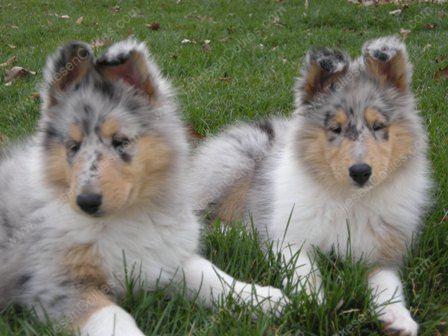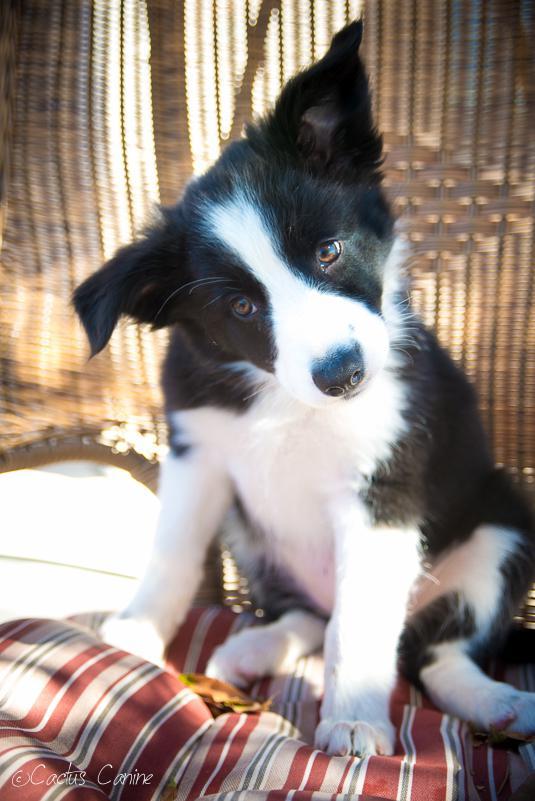The first image is the image on the left, the second image is the image on the right. Assess this claim about the two images: "There is a total of three dogs.". Correct or not? Answer yes or no. Yes. The first image is the image on the left, the second image is the image on the right. Evaluate the accuracy of this statement regarding the images: "The right image contains exactly one dog.". Is it true? Answer yes or no. Yes. 